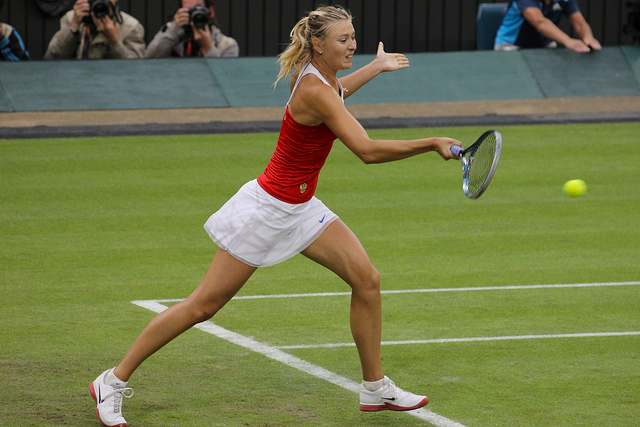<image>What color hat is this person wearing? The person is not wearing a hat. What color hat is this person wearing? There is no hat on the person in the image. 